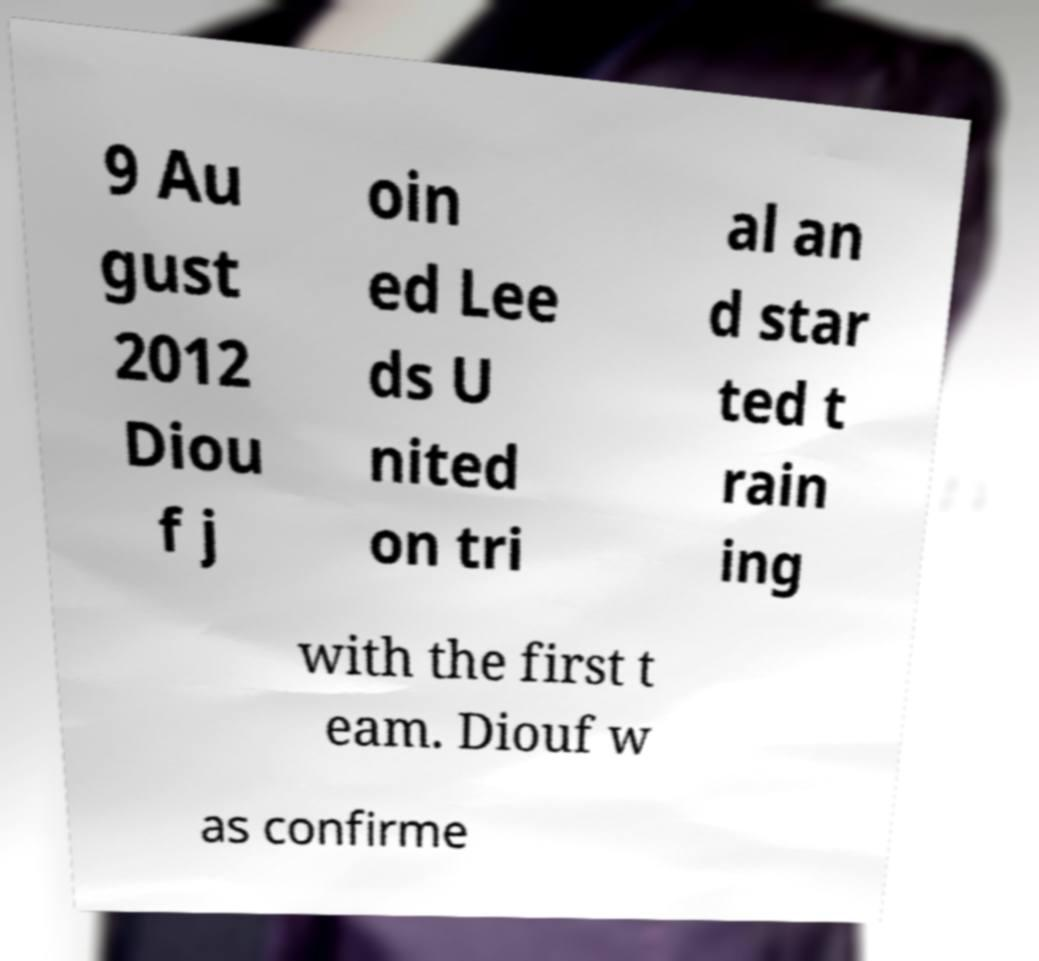Please read and relay the text visible in this image. What does it say? 9 Au gust 2012 Diou f j oin ed Lee ds U nited on tri al an d star ted t rain ing with the first t eam. Diouf w as confirme 